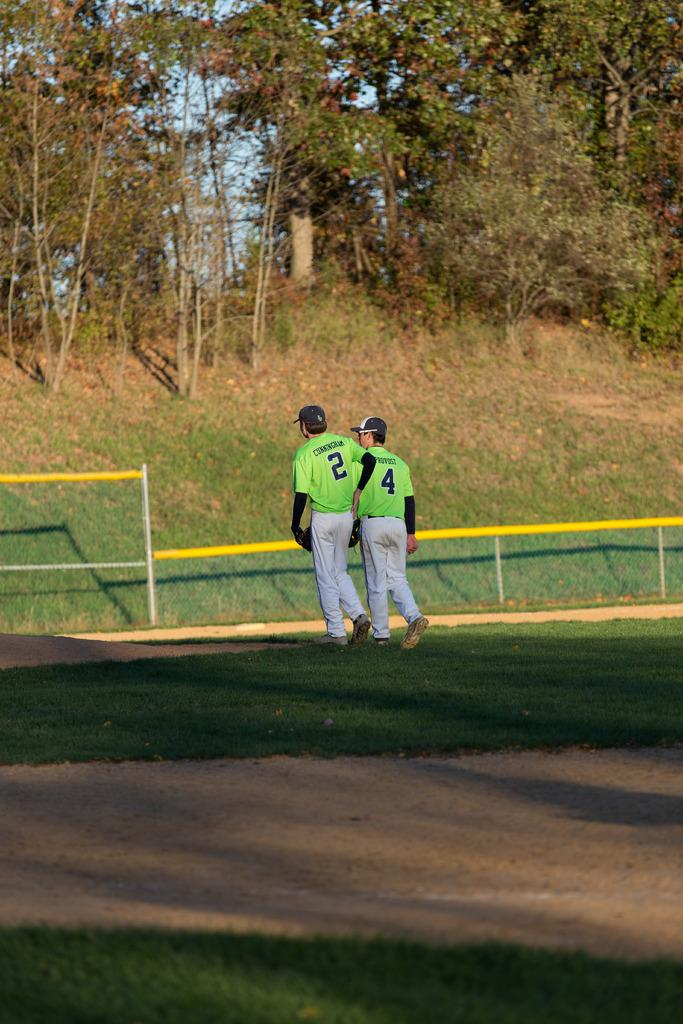How many people are in the image? There are two persons in the image. What are the people wearing on their upper bodies? Both persons are wearing green color T-shirts. What are the people wearing on their lower bodies? Both persons are wearing white color pants. What are the people wearing on their heads? Both persons are wearing black color caps. What can be seen in the background of the image? There is fencing and trees in the background of the image. Can you see a twig in the person's hand in the image? There is no twig visible in the hands of the persons in the image. What type of ground can be seen beneath the people in the image? The image does not provide enough information to determine the type of ground beneath the people. 